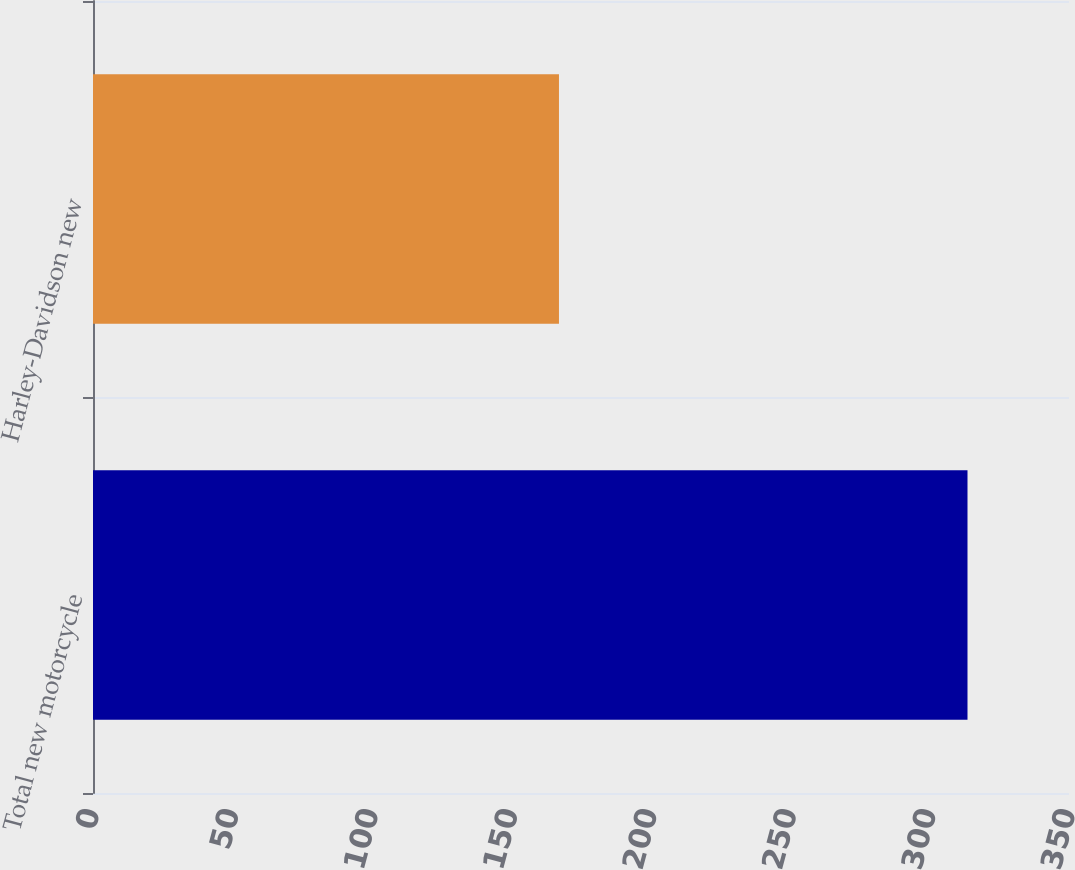<chart> <loc_0><loc_0><loc_500><loc_500><bar_chart><fcel>Total new motorcycle<fcel>Harley-Davidson new<nl><fcel>313.6<fcel>167.1<nl></chart> 